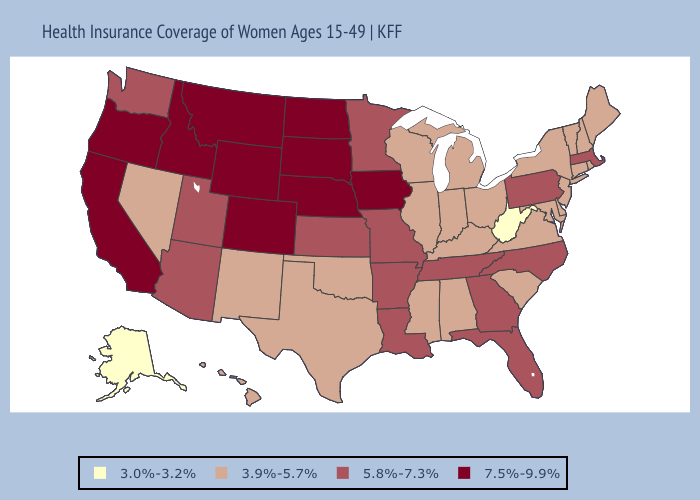Does Washington have the highest value in the USA?
Concise answer only. No. What is the lowest value in the South?
Concise answer only. 3.0%-3.2%. Among the states that border Arizona , which have the lowest value?
Concise answer only. Nevada, New Mexico. What is the highest value in states that border Michigan?
Be succinct. 3.9%-5.7%. Does West Virginia have the lowest value in the USA?
Concise answer only. Yes. Does Pennsylvania have the lowest value in the Northeast?
Keep it brief. No. What is the value of Georgia?
Write a very short answer. 5.8%-7.3%. Does South Dakota have the highest value in the USA?
Short answer required. Yes. Name the states that have a value in the range 7.5%-9.9%?
Short answer required. California, Colorado, Idaho, Iowa, Montana, Nebraska, North Dakota, Oregon, South Dakota, Wyoming. Name the states that have a value in the range 7.5%-9.9%?
Short answer required. California, Colorado, Idaho, Iowa, Montana, Nebraska, North Dakota, Oregon, South Dakota, Wyoming. Does New Jersey have a higher value than West Virginia?
Concise answer only. Yes. Among the states that border Pennsylvania , which have the lowest value?
Keep it brief. West Virginia. What is the value of Idaho?
Answer briefly. 7.5%-9.9%. Which states have the highest value in the USA?
Answer briefly. California, Colorado, Idaho, Iowa, Montana, Nebraska, North Dakota, Oregon, South Dakota, Wyoming. Does Maine have a higher value than Alaska?
Concise answer only. Yes. 